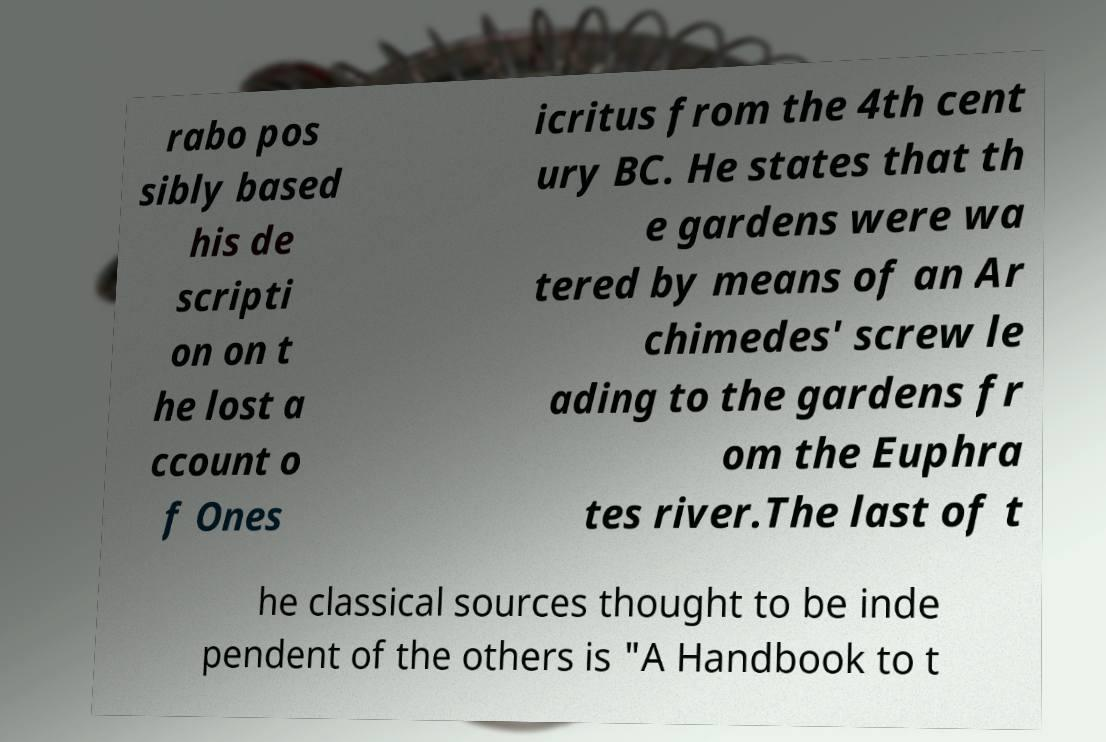Can you accurately transcribe the text from the provided image for me? rabo pos sibly based his de scripti on on t he lost a ccount o f Ones icritus from the 4th cent ury BC. He states that th e gardens were wa tered by means of an Ar chimedes' screw le ading to the gardens fr om the Euphra tes river.The last of t he classical sources thought to be inde pendent of the others is "A Handbook to t 